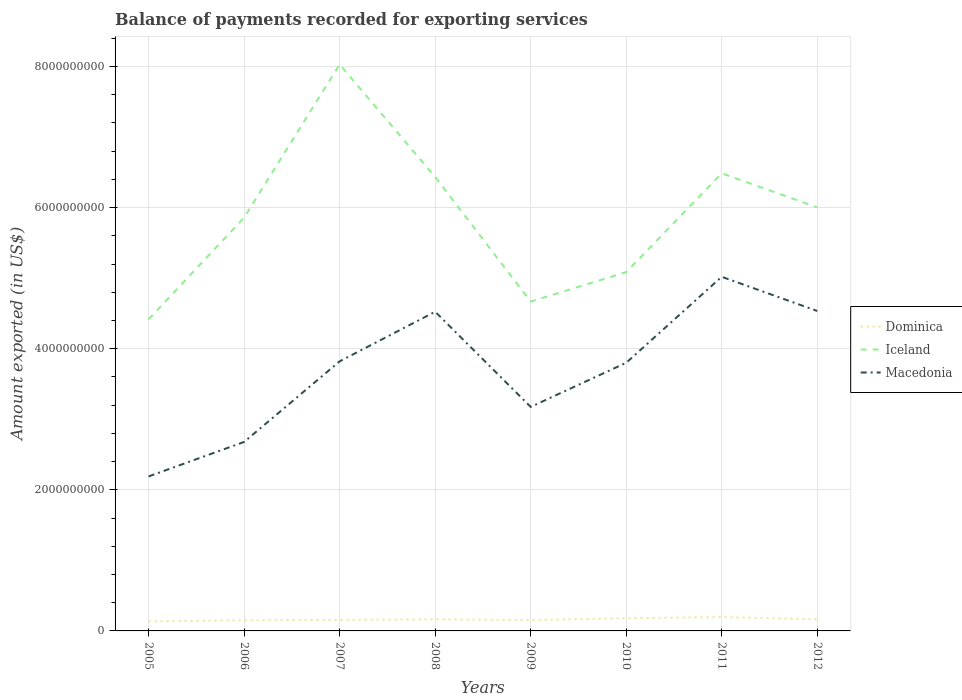Across all years, what is the maximum amount exported in Iceland?
Your answer should be very brief. 4.42e+09. In which year was the amount exported in Iceland maximum?
Your response must be concise. 2005. What is the total amount exported in Dominica in the graph?
Keep it short and to the point. -1.92e+07. What is the difference between the highest and the second highest amount exported in Iceland?
Make the answer very short. 3.61e+09. What is the difference between the highest and the lowest amount exported in Macedonia?
Provide a short and direct response. 5. How many years are there in the graph?
Your answer should be compact. 8. Does the graph contain any zero values?
Your response must be concise. No. Does the graph contain grids?
Offer a terse response. Yes. How are the legend labels stacked?
Keep it short and to the point. Vertical. What is the title of the graph?
Ensure brevity in your answer.  Balance of payments recorded for exporting services. Does "Albania" appear as one of the legend labels in the graph?
Give a very brief answer. No. What is the label or title of the X-axis?
Keep it short and to the point. Years. What is the label or title of the Y-axis?
Your answer should be very brief. Amount exported (in US$). What is the Amount exported (in US$) in Dominica in 2005?
Ensure brevity in your answer.  1.35e+08. What is the Amount exported (in US$) of Iceland in 2005?
Provide a short and direct response. 4.42e+09. What is the Amount exported (in US$) in Macedonia in 2005?
Provide a succinct answer. 2.19e+09. What is the Amount exported (in US$) in Dominica in 2006?
Your answer should be very brief. 1.51e+08. What is the Amount exported (in US$) in Iceland in 2006?
Your answer should be very brief. 5.86e+09. What is the Amount exported (in US$) of Macedonia in 2006?
Give a very brief answer. 2.68e+09. What is the Amount exported (in US$) of Dominica in 2007?
Offer a very short reply. 1.56e+08. What is the Amount exported (in US$) of Iceland in 2007?
Keep it short and to the point. 8.03e+09. What is the Amount exported (in US$) of Macedonia in 2007?
Keep it short and to the point. 3.82e+09. What is the Amount exported (in US$) of Dominica in 2008?
Ensure brevity in your answer.  1.65e+08. What is the Amount exported (in US$) in Iceland in 2008?
Offer a very short reply. 6.43e+09. What is the Amount exported (in US$) in Macedonia in 2008?
Make the answer very short. 4.52e+09. What is the Amount exported (in US$) in Dominica in 2009?
Keep it short and to the point. 1.55e+08. What is the Amount exported (in US$) of Iceland in 2009?
Your answer should be very brief. 4.67e+09. What is the Amount exported (in US$) in Macedonia in 2009?
Keep it short and to the point. 3.18e+09. What is the Amount exported (in US$) of Dominica in 2010?
Keep it short and to the point. 1.80e+08. What is the Amount exported (in US$) of Iceland in 2010?
Make the answer very short. 5.08e+09. What is the Amount exported (in US$) of Macedonia in 2010?
Provide a short and direct response. 3.80e+09. What is the Amount exported (in US$) of Dominica in 2011?
Your answer should be very brief. 1.96e+08. What is the Amount exported (in US$) in Iceland in 2011?
Your response must be concise. 6.49e+09. What is the Amount exported (in US$) of Macedonia in 2011?
Your response must be concise. 5.02e+09. What is the Amount exported (in US$) in Dominica in 2012?
Offer a very short reply. 1.65e+08. What is the Amount exported (in US$) in Iceland in 2012?
Give a very brief answer. 6.00e+09. What is the Amount exported (in US$) of Macedonia in 2012?
Ensure brevity in your answer.  4.53e+09. Across all years, what is the maximum Amount exported (in US$) in Dominica?
Provide a succinct answer. 1.96e+08. Across all years, what is the maximum Amount exported (in US$) of Iceland?
Your response must be concise. 8.03e+09. Across all years, what is the maximum Amount exported (in US$) in Macedonia?
Keep it short and to the point. 5.02e+09. Across all years, what is the minimum Amount exported (in US$) in Dominica?
Make the answer very short. 1.35e+08. Across all years, what is the minimum Amount exported (in US$) in Iceland?
Ensure brevity in your answer.  4.42e+09. Across all years, what is the minimum Amount exported (in US$) of Macedonia?
Provide a succinct answer. 2.19e+09. What is the total Amount exported (in US$) of Dominica in the graph?
Offer a very short reply. 1.30e+09. What is the total Amount exported (in US$) in Iceland in the graph?
Your response must be concise. 4.70e+1. What is the total Amount exported (in US$) in Macedonia in the graph?
Your response must be concise. 2.97e+1. What is the difference between the Amount exported (in US$) of Dominica in 2005 and that in 2006?
Your answer should be very brief. -1.53e+07. What is the difference between the Amount exported (in US$) in Iceland in 2005 and that in 2006?
Offer a terse response. -1.44e+09. What is the difference between the Amount exported (in US$) of Macedonia in 2005 and that in 2006?
Your answer should be compact. -4.89e+08. What is the difference between the Amount exported (in US$) of Dominica in 2005 and that in 2007?
Provide a short and direct response. -2.11e+07. What is the difference between the Amount exported (in US$) in Iceland in 2005 and that in 2007?
Provide a succinct answer. -3.61e+09. What is the difference between the Amount exported (in US$) of Macedonia in 2005 and that in 2007?
Your answer should be compact. -1.63e+09. What is the difference between the Amount exported (in US$) of Dominica in 2005 and that in 2008?
Provide a short and direct response. -2.99e+07. What is the difference between the Amount exported (in US$) of Iceland in 2005 and that in 2008?
Offer a very short reply. -2.02e+09. What is the difference between the Amount exported (in US$) in Macedonia in 2005 and that in 2008?
Provide a short and direct response. -2.33e+09. What is the difference between the Amount exported (in US$) in Dominica in 2005 and that in 2009?
Provide a short and direct response. -1.92e+07. What is the difference between the Amount exported (in US$) in Iceland in 2005 and that in 2009?
Your answer should be very brief. -2.52e+08. What is the difference between the Amount exported (in US$) of Macedonia in 2005 and that in 2009?
Provide a short and direct response. -9.85e+08. What is the difference between the Amount exported (in US$) of Dominica in 2005 and that in 2010?
Your response must be concise. -4.49e+07. What is the difference between the Amount exported (in US$) in Iceland in 2005 and that in 2010?
Make the answer very short. -6.69e+08. What is the difference between the Amount exported (in US$) in Macedonia in 2005 and that in 2010?
Offer a very short reply. -1.61e+09. What is the difference between the Amount exported (in US$) in Dominica in 2005 and that in 2011?
Offer a terse response. -6.06e+07. What is the difference between the Amount exported (in US$) of Iceland in 2005 and that in 2011?
Provide a succinct answer. -2.07e+09. What is the difference between the Amount exported (in US$) of Macedonia in 2005 and that in 2011?
Keep it short and to the point. -2.83e+09. What is the difference between the Amount exported (in US$) of Dominica in 2005 and that in 2012?
Provide a succinct answer. -2.98e+07. What is the difference between the Amount exported (in US$) in Iceland in 2005 and that in 2012?
Give a very brief answer. -1.59e+09. What is the difference between the Amount exported (in US$) of Macedonia in 2005 and that in 2012?
Offer a very short reply. -2.34e+09. What is the difference between the Amount exported (in US$) of Dominica in 2006 and that in 2007?
Your answer should be compact. -5.78e+06. What is the difference between the Amount exported (in US$) in Iceland in 2006 and that in 2007?
Your response must be concise. -2.17e+09. What is the difference between the Amount exported (in US$) of Macedonia in 2006 and that in 2007?
Provide a short and direct response. -1.14e+09. What is the difference between the Amount exported (in US$) in Dominica in 2006 and that in 2008?
Give a very brief answer. -1.46e+07. What is the difference between the Amount exported (in US$) in Iceland in 2006 and that in 2008?
Keep it short and to the point. -5.76e+08. What is the difference between the Amount exported (in US$) of Macedonia in 2006 and that in 2008?
Ensure brevity in your answer.  -1.85e+09. What is the difference between the Amount exported (in US$) in Dominica in 2006 and that in 2009?
Keep it short and to the point. -3.92e+06. What is the difference between the Amount exported (in US$) of Iceland in 2006 and that in 2009?
Your answer should be compact. 1.19e+09. What is the difference between the Amount exported (in US$) of Macedonia in 2006 and that in 2009?
Your answer should be compact. -4.97e+08. What is the difference between the Amount exported (in US$) in Dominica in 2006 and that in 2010?
Keep it short and to the point. -2.96e+07. What is the difference between the Amount exported (in US$) in Iceland in 2006 and that in 2010?
Provide a short and direct response. 7.73e+08. What is the difference between the Amount exported (in US$) in Macedonia in 2006 and that in 2010?
Offer a very short reply. -1.12e+09. What is the difference between the Amount exported (in US$) of Dominica in 2006 and that in 2011?
Provide a short and direct response. -4.53e+07. What is the difference between the Amount exported (in US$) of Iceland in 2006 and that in 2011?
Offer a terse response. -6.27e+08. What is the difference between the Amount exported (in US$) of Macedonia in 2006 and that in 2011?
Offer a very short reply. -2.34e+09. What is the difference between the Amount exported (in US$) in Dominica in 2006 and that in 2012?
Make the answer very short. -1.44e+07. What is the difference between the Amount exported (in US$) in Iceland in 2006 and that in 2012?
Your answer should be very brief. -1.45e+08. What is the difference between the Amount exported (in US$) in Macedonia in 2006 and that in 2012?
Make the answer very short. -1.86e+09. What is the difference between the Amount exported (in US$) of Dominica in 2007 and that in 2008?
Offer a very short reply. -8.77e+06. What is the difference between the Amount exported (in US$) in Iceland in 2007 and that in 2008?
Make the answer very short. 1.60e+09. What is the difference between the Amount exported (in US$) of Macedonia in 2007 and that in 2008?
Your answer should be compact. -7.03e+08. What is the difference between the Amount exported (in US$) of Dominica in 2007 and that in 2009?
Provide a succinct answer. 1.87e+06. What is the difference between the Amount exported (in US$) of Iceland in 2007 and that in 2009?
Provide a succinct answer. 3.36e+09. What is the difference between the Amount exported (in US$) of Macedonia in 2007 and that in 2009?
Make the answer very short. 6.46e+08. What is the difference between the Amount exported (in US$) of Dominica in 2007 and that in 2010?
Offer a very short reply. -2.38e+07. What is the difference between the Amount exported (in US$) of Iceland in 2007 and that in 2010?
Ensure brevity in your answer.  2.94e+09. What is the difference between the Amount exported (in US$) of Macedonia in 2007 and that in 2010?
Your answer should be very brief. 2.02e+07. What is the difference between the Amount exported (in US$) in Dominica in 2007 and that in 2011?
Keep it short and to the point. -3.95e+07. What is the difference between the Amount exported (in US$) of Iceland in 2007 and that in 2011?
Your answer should be compact. 1.54e+09. What is the difference between the Amount exported (in US$) of Macedonia in 2007 and that in 2011?
Provide a succinct answer. -1.20e+09. What is the difference between the Amount exported (in US$) in Dominica in 2007 and that in 2012?
Ensure brevity in your answer.  -8.67e+06. What is the difference between the Amount exported (in US$) in Iceland in 2007 and that in 2012?
Offer a terse response. 2.03e+09. What is the difference between the Amount exported (in US$) in Macedonia in 2007 and that in 2012?
Your response must be concise. -7.14e+08. What is the difference between the Amount exported (in US$) in Dominica in 2008 and that in 2009?
Offer a very short reply. 1.06e+07. What is the difference between the Amount exported (in US$) in Iceland in 2008 and that in 2009?
Ensure brevity in your answer.  1.77e+09. What is the difference between the Amount exported (in US$) of Macedonia in 2008 and that in 2009?
Keep it short and to the point. 1.35e+09. What is the difference between the Amount exported (in US$) in Dominica in 2008 and that in 2010?
Keep it short and to the point. -1.50e+07. What is the difference between the Amount exported (in US$) in Iceland in 2008 and that in 2010?
Provide a short and direct response. 1.35e+09. What is the difference between the Amount exported (in US$) of Macedonia in 2008 and that in 2010?
Offer a terse response. 7.23e+08. What is the difference between the Amount exported (in US$) in Dominica in 2008 and that in 2011?
Keep it short and to the point. -3.07e+07. What is the difference between the Amount exported (in US$) of Iceland in 2008 and that in 2011?
Make the answer very short. -5.18e+07. What is the difference between the Amount exported (in US$) of Macedonia in 2008 and that in 2011?
Offer a very short reply. -4.95e+08. What is the difference between the Amount exported (in US$) of Dominica in 2008 and that in 2012?
Provide a short and direct response. 1.01e+05. What is the difference between the Amount exported (in US$) in Iceland in 2008 and that in 2012?
Ensure brevity in your answer.  4.31e+08. What is the difference between the Amount exported (in US$) of Macedonia in 2008 and that in 2012?
Ensure brevity in your answer.  -1.05e+07. What is the difference between the Amount exported (in US$) in Dominica in 2009 and that in 2010?
Your response must be concise. -2.56e+07. What is the difference between the Amount exported (in US$) in Iceland in 2009 and that in 2010?
Provide a short and direct response. -4.17e+08. What is the difference between the Amount exported (in US$) of Macedonia in 2009 and that in 2010?
Keep it short and to the point. -6.26e+08. What is the difference between the Amount exported (in US$) in Dominica in 2009 and that in 2011?
Provide a short and direct response. -4.14e+07. What is the difference between the Amount exported (in US$) in Iceland in 2009 and that in 2011?
Your answer should be very brief. -1.82e+09. What is the difference between the Amount exported (in US$) in Macedonia in 2009 and that in 2011?
Make the answer very short. -1.84e+09. What is the difference between the Amount exported (in US$) in Dominica in 2009 and that in 2012?
Offer a very short reply. -1.05e+07. What is the difference between the Amount exported (in US$) in Iceland in 2009 and that in 2012?
Your answer should be compact. -1.33e+09. What is the difference between the Amount exported (in US$) of Macedonia in 2009 and that in 2012?
Ensure brevity in your answer.  -1.36e+09. What is the difference between the Amount exported (in US$) of Dominica in 2010 and that in 2011?
Provide a short and direct response. -1.57e+07. What is the difference between the Amount exported (in US$) in Iceland in 2010 and that in 2011?
Give a very brief answer. -1.40e+09. What is the difference between the Amount exported (in US$) in Macedonia in 2010 and that in 2011?
Your answer should be compact. -1.22e+09. What is the difference between the Amount exported (in US$) of Dominica in 2010 and that in 2012?
Your response must be concise. 1.51e+07. What is the difference between the Amount exported (in US$) of Iceland in 2010 and that in 2012?
Your answer should be compact. -9.18e+08. What is the difference between the Amount exported (in US$) of Macedonia in 2010 and that in 2012?
Give a very brief answer. -7.34e+08. What is the difference between the Amount exported (in US$) in Dominica in 2011 and that in 2012?
Offer a very short reply. 3.08e+07. What is the difference between the Amount exported (in US$) of Iceland in 2011 and that in 2012?
Ensure brevity in your answer.  4.83e+08. What is the difference between the Amount exported (in US$) of Macedonia in 2011 and that in 2012?
Ensure brevity in your answer.  4.85e+08. What is the difference between the Amount exported (in US$) in Dominica in 2005 and the Amount exported (in US$) in Iceland in 2006?
Your response must be concise. -5.72e+09. What is the difference between the Amount exported (in US$) in Dominica in 2005 and the Amount exported (in US$) in Macedonia in 2006?
Offer a terse response. -2.54e+09. What is the difference between the Amount exported (in US$) of Iceland in 2005 and the Amount exported (in US$) of Macedonia in 2006?
Make the answer very short. 1.74e+09. What is the difference between the Amount exported (in US$) of Dominica in 2005 and the Amount exported (in US$) of Iceland in 2007?
Give a very brief answer. -7.89e+09. What is the difference between the Amount exported (in US$) in Dominica in 2005 and the Amount exported (in US$) in Macedonia in 2007?
Provide a short and direct response. -3.69e+09. What is the difference between the Amount exported (in US$) in Iceland in 2005 and the Amount exported (in US$) in Macedonia in 2007?
Keep it short and to the point. 5.95e+08. What is the difference between the Amount exported (in US$) in Dominica in 2005 and the Amount exported (in US$) in Iceland in 2008?
Your response must be concise. -6.30e+09. What is the difference between the Amount exported (in US$) of Dominica in 2005 and the Amount exported (in US$) of Macedonia in 2008?
Provide a short and direct response. -4.39e+09. What is the difference between the Amount exported (in US$) of Iceland in 2005 and the Amount exported (in US$) of Macedonia in 2008?
Ensure brevity in your answer.  -1.08e+08. What is the difference between the Amount exported (in US$) of Dominica in 2005 and the Amount exported (in US$) of Iceland in 2009?
Ensure brevity in your answer.  -4.53e+09. What is the difference between the Amount exported (in US$) in Dominica in 2005 and the Amount exported (in US$) in Macedonia in 2009?
Your answer should be compact. -3.04e+09. What is the difference between the Amount exported (in US$) of Iceland in 2005 and the Amount exported (in US$) of Macedonia in 2009?
Keep it short and to the point. 1.24e+09. What is the difference between the Amount exported (in US$) in Dominica in 2005 and the Amount exported (in US$) in Iceland in 2010?
Offer a terse response. -4.95e+09. What is the difference between the Amount exported (in US$) in Dominica in 2005 and the Amount exported (in US$) in Macedonia in 2010?
Give a very brief answer. -3.67e+09. What is the difference between the Amount exported (in US$) in Iceland in 2005 and the Amount exported (in US$) in Macedonia in 2010?
Your response must be concise. 6.15e+08. What is the difference between the Amount exported (in US$) of Dominica in 2005 and the Amount exported (in US$) of Iceland in 2011?
Give a very brief answer. -6.35e+09. What is the difference between the Amount exported (in US$) in Dominica in 2005 and the Amount exported (in US$) in Macedonia in 2011?
Ensure brevity in your answer.  -4.88e+09. What is the difference between the Amount exported (in US$) in Iceland in 2005 and the Amount exported (in US$) in Macedonia in 2011?
Your response must be concise. -6.04e+08. What is the difference between the Amount exported (in US$) of Dominica in 2005 and the Amount exported (in US$) of Iceland in 2012?
Provide a short and direct response. -5.87e+09. What is the difference between the Amount exported (in US$) of Dominica in 2005 and the Amount exported (in US$) of Macedonia in 2012?
Provide a short and direct response. -4.40e+09. What is the difference between the Amount exported (in US$) of Iceland in 2005 and the Amount exported (in US$) of Macedonia in 2012?
Give a very brief answer. -1.19e+08. What is the difference between the Amount exported (in US$) of Dominica in 2006 and the Amount exported (in US$) of Iceland in 2007?
Your answer should be very brief. -7.88e+09. What is the difference between the Amount exported (in US$) of Dominica in 2006 and the Amount exported (in US$) of Macedonia in 2007?
Your response must be concise. -3.67e+09. What is the difference between the Amount exported (in US$) of Iceland in 2006 and the Amount exported (in US$) of Macedonia in 2007?
Make the answer very short. 2.04e+09. What is the difference between the Amount exported (in US$) of Dominica in 2006 and the Amount exported (in US$) of Iceland in 2008?
Your response must be concise. -6.28e+09. What is the difference between the Amount exported (in US$) in Dominica in 2006 and the Amount exported (in US$) in Macedonia in 2008?
Offer a very short reply. -4.37e+09. What is the difference between the Amount exported (in US$) in Iceland in 2006 and the Amount exported (in US$) in Macedonia in 2008?
Your response must be concise. 1.33e+09. What is the difference between the Amount exported (in US$) of Dominica in 2006 and the Amount exported (in US$) of Iceland in 2009?
Your answer should be very brief. -4.52e+09. What is the difference between the Amount exported (in US$) of Dominica in 2006 and the Amount exported (in US$) of Macedonia in 2009?
Provide a short and direct response. -3.02e+09. What is the difference between the Amount exported (in US$) of Iceland in 2006 and the Amount exported (in US$) of Macedonia in 2009?
Provide a short and direct response. 2.68e+09. What is the difference between the Amount exported (in US$) of Dominica in 2006 and the Amount exported (in US$) of Iceland in 2010?
Provide a succinct answer. -4.93e+09. What is the difference between the Amount exported (in US$) in Dominica in 2006 and the Amount exported (in US$) in Macedonia in 2010?
Offer a very short reply. -3.65e+09. What is the difference between the Amount exported (in US$) in Iceland in 2006 and the Amount exported (in US$) in Macedonia in 2010?
Offer a very short reply. 2.06e+09. What is the difference between the Amount exported (in US$) of Dominica in 2006 and the Amount exported (in US$) of Iceland in 2011?
Give a very brief answer. -6.33e+09. What is the difference between the Amount exported (in US$) in Dominica in 2006 and the Amount exported (in US$) in Macedonia in 2011?
Offer a very short reply. -4.87e+09. What is the difference between the Amount exported (in US$) of Iceland in 2006 and the Amount exported (in US$) of Macedonia in 2011?
Your answer should be very brief. 8.39e+08. What is the difference between the Amount exported (in US$) in Dominica in 2006 and the Amount exported (in US$) in Iceland in 2012?
Your answer should be compact. -5.85e+09. What is the difference between the Amount exported (in US$) of Dominica in 2006 and the Amount exported (in US$) of Macedonia in 2012?
Make the answer very short. -4.38e+09. What is the difference between the Amount exported (in US$) in Iceland in 2006 and the Amount exported (in US$) in Macedonia in 2012?
Give a very brief answer. 1.32e+09. What is the difference between the Amount exported (in US$) in Dominica in 2007 and the Amount exported (in US$) in Iceland in 2008?
Keep it short and to the point. -6.28e+09. What is the difference between the Amount exported (in US$) of Dominica in 2007 and the Amount exported (in US$) of Macedonia in 2008?
Offer a very short reply. -4.37e+09. What is the difference between the Amount exported (in US$) of Iceland in 2007 and the Amount exported (in US$) of Macedonia in 2008?
Ensure brevity in your answer.  3.51e+09. What is the difference between the Amount exported (in US$) of Dominica in 2007 and the Amount exported (in US$) of Iceland in 2009?
Provide a short and direct response. -4.51e+09. What is the difference between the Amount exported (in US$) of Dominica in 2007 and the Amount exported (in US$) of Macedonia in 2009?
Your answer should be very brief. -3.02e+09. What is the difference between the Amount exported (in US$) of Iceland in 2007 and the Amount exported (in US$) of Macedonia in 2009?
Your answer should be compact. 4.85e+09. What is the difference between the Amount exported (in US$) in Dominica in 2007 and the Amount exported (in US$) in Iceland in 2010?
Provide a succinct answer. -4.93e+09. What is the difference between the Amount exported (in US$) in Dominica in 2007 and the Amount exported (in US$) in Macedonia in 2010?
Your response must be concise. -3.64e+09. What is the difference between the Amount exported (in US$) of Iceland in 2007 and the Amount exported (in US$) of Macedonia in 2010?
Offer a very short reply. 4.23e+09. What is the difference between the Amount exported (in US$) in Dominica in 2007 and the Amount exported (in US$) in Iceland in 2011?
Offer a terse response. -6.33e+09. What is the difference between the Amount exported (in US$) in Dominica in 2007 and the Amount exported (in US$) in Macedonia in 2011?
Provide a succinct answer. -4.86e+09. What is the difference between the Amount exported (in US$) of Iceland in 2007 and the Amount exported (in US$) of Macedonia in 2011?
Offer a terse response. 3.01e+09. What is the difference between the Amount exported (in US$) in Dominica in 2007 and the Amount exported (in US$) in Iceland in 2012?
Your answer should be compact. -5.85e+09. What is the difference between the Amount exported (in US$) of Dominica in 2007 and the Amount exported (in US$) of Macedonia in 2012?
Your answer should be compact. -4.38e+09. What is the difference between the Amount exported (in US$) in Iceland in 2007 and the Amount exported (in US$) in Macedonia in 2012?
Offer a terse response. 3.49e+09. What is the difference between the Amount exported (in US$) in Dominica in 2008 and the Amount exported (in US$) in Iceland in 2009?
Provide a short and direct response. -4.50e+09. What is the difference between the Amount exported (in US$) in Dominica in 2008 and the Amount exported (in US$) in Macedonia in 2009?
Ensure brevity in your answer.  -3.01e+09. What is the difference between the Amount exported (in US$) in Iceland in 2008 and the Amount exported (in US$) in Macedonia in 2009?
Ensure brevity in your answer.  3.26e+09. What is the difference between the Amount exported (in US$) in Dominica in 2008 and the Amount exported (in US$) in Iceland in 2010?
Ensure brevity in your answer.  -4.92e+09. What is the difference between the Amount exported (in US$) in Dominica in 2008 and the Amount exported (in US$) in Macedonia in 2010?
Your answer should be very brief. -3.64e+09. What is the difference between the Amount exported (in US$) in Iceland in 2008 and the Amount exported (in US$) in Macedonia in 2010?
Provide a short and direct response. 2.63e+09. What is the difference between the Amount exported (in US$) of Dominica in 2008 and the Amount exported (in US$) of Iceland in 2011?
Offer a terse response. -6.32e+09. What is the difference between the Amount exported (in US$) in Dominica in 2008 and the Amount exported (in US$) in Macedonia in 2011?
Make the answer very short. -4.85e+09. What is the difference between the Amount exported (in US$) of Iceland in 2008 and the Amount exported (in US$) of Macedonia in 2011?
Keep it short and to the point. 1.41e+09. What is the difference between the Amount exported (in US$) of Dominica in 2008 and the Amount exported (in US$) of Iceland in 2012?
Ensure brevity in your answer.  -5.84e+09. What is the difference between the Amount exported (in US$) of Dominica in 2008 and the Amount exported (in US$) of Macedonia in 2012?
Make the answer very short. -4.37e+09. What is the difference between the Amount exported (in US$) in Iceland in 2008 and the Amount exported (in US$) in Macedonia in 2012?
Your response must be concise. 1.90e+09. What is the difference between the Amount exported (in US$) in Dominica in 2009 and the Amount exported (in US$) in Iceland in 2010?
Offer a terse response. -4.93e+09. What is the difference between the Amount exported (in US$) of Dominica in 2009 and the Amount exported (in US$) of Macedonia in 2010?
Your response must be concise. -3.65e+09. What is the difference between the Amount exported (in US$) of Iceland in 2009 and the Amount exported (in US$) of Macedonia in 2010?
Your answer should be compact. 8.67e+08. What is the difference between the Amount exported (in US$) in Dominica in 2009 and the Amount exported (in US$) in Iceland in 2011?
Offer a very short reply. -6.33e+09. What is the difference between the Amount exported (in US$) of Dominica in 2009 and the Amount exported (in US$) of Macedonia in 2011?
Make the answer very short. -4.86e+09. What is the difference between the Amount exported (in US$) in Iceland in 2009 and the Amount exported (in US$) in Macedonia in 2011?
Your answer should be very brief. -3.51e+08. What is the difference between the Amount exported (in US$) in Dominica in 2009 and the Amount exported (in US$) in Iceland in 2012?
Offer a terse response. -5.85e+09. What is the difference between the Amount exported (in US$) of Dominica in 2009 and the Amount exported (in US$) of Macedonia in 2012?
Your response must be concise. -4.38e+09. What is the difference between the Amount exported (in US$) of Iceland in 2009 and the Amount exported (in US$) of Macedonia in 2012?
Your response must be concise. 1.33e+08. What is the difference between the Amount exported (in US$) in Dominica in 2010 and the Amount exported (in US$) in Iceland in 2011?
Make the answer very short. -6.31e+09. What is the difference between the Amount exported (in US$) of Dominica in 2010 and the Amount exported (in US$) of Macedonia in 2011?
Your response must be concise. -4.84e+09. What is the difference between the Amount exported (in US$) in Iceland in 2010 and the Amount exported (in US$) in Macedonia in 2011?
Offer a very short reply. 6.56e+07. What is the difference between the Amount exported (in US$) of Dominica in 2010 and the Amount exported (in US$) of Iceland in 2012?
Give a very brief answer. -5.82e+09. What is the difference between the Amount exported (in US$) in Dominica in 2010 and the Amount exported (in US$) in Macedonia in 2012?
Give a very brief answer. -4.35e+09. What is the difference between the Amount exported (in US$) in Iceland in 2010 and the Amount exported (in US$) in Macedonia in 2012?
Provide a succinct answer. 5.50e+08. What is the difference between the Amount exported (in US$) in Dominica in 2011 and the Amount exported (in US$) in Iceland in 2012?
Keep it short and to the point. -5.81e+09. What is the difference between the Amount exported (in US$) in Dominica in 2011 and the Amount exported (in US$) in Macedonia in 2012?
Keep it short and to the point. -4.34e+09. What is the difference between the Amount exported (in US$) in Iceland in 2011 and the Amount exported (in US$) in Macedonia in 2012?
Keep it short and to the point. 1.95e+09. What is the average Amount exported (in US$) of Dominica per year?
Your answer should be compact. 1.63e+08. What is the average Amount exported (in US$) in Iceland per year?
Ensure brevity in your answer.  5.87e+09. What is the average Amount exported (in US$) in Macedonia per year?
Make the answer very short. 3.72e+09. In the year 2005, what is the difference between the Amount exported (in US$) in Dominica and Amount exported (in US$) in Iceland?
Provide a short and direct response. -4.28e+09. In the year 2005, what is the difference between the Amount exported (in US$) of Dominica and Amount exported (in US$) of Macedonia?
Give a very brief answer. -2.05e+09. In the year 2005, what is the difference between the Amount exported (in US$) of Iceland and Amount exported (in US$) of Macedonia?
Your response must be concise. 2.23e+09. In the year 2006, what is the difference between the Amount exported (in US$) in Dominica and Amount exported (in US$) in Iceland?
Provide a short and direct response. -5.71e+09. In the year 2006, what is the difference between the Amount exported (in US$) in Dominica and Amount exported (in US$) in Macedonia?
Give a very brief answer. -2.53e+09. In the year 2006, what is the difference between the Amount exported (in US$) in Iceland and Amount exported (in US$) in Macedonia?
Your answer should be compact. 3.18e+09. In the year 2007, what is the difference between the Amount exported (in US$) of Dominica and Amount exported (in US$) of Iceland?
Ensure brevity in your answer.  -7.87e+09. In the year 2007, what is the difference between the Amount exported (in US$) of Dominica and Amount exported (in US$) of Macedonia?
Give a very brief answer. -3.66e+09. In the year 2007, what is the difference between the Amount exported (in US$) in Iceland and Amount exported (in US$) in Macedonia?
Offer a terse response. 4.21e+09. In the year 2008, what is the difference between the Amount exported (in US$) in Dominica and Amount exported (in US$) in Iceland?
Offer a very short reply. -6.27e+09. In the year 2008, what is the difference between the Amount exported (in US$) in Dominica and Amount exported (in US$) in Macedonia?
Offer a terse response. -4.36e+09. In the year 2008, what is the difference between the Amount exported (in US$) of Iceland and Amount exported (in US$) of Macedonia?
Your answer should be very brief. 1.91e+09. In the year 2009, what is the difference between the Amount exported (in US$) in Dominica and Amount exported (in US$) in Iceland?
Keep it short and to the point. -4.51e+09. In the year 2009, what is the difference between the Amount exported (in US$) in Dominica and Amount exported (in US$) in Macedonia?
Provide a succinct answer. -3.02e+09. In the year 2009, what is the difference between the Amount exported (in US$) in Iceland and Amount exported (in US$) in Macedonia?
Keep it short and to the point. 1.49e+09. In the year 2010, what is the difference between the Amount exported (in US$) in Dominica and Amount exported (in US$) in Iceland?
Offer a terse response. -4.90e+09. In the year 2010, what is the difference between the Amount exported (in US$) in Dominica and Amount exported (in US$) in Macedonia?
Your response must be concise. -3.62e+09. In the year 2010, what is the difference between the Amount exported (in US$) of Iceland and Amount exported (in US$) of Macedonia?
Give a very brief answer. 1.28e+09. In the year 2011, what is the difference between the Amount exported (in US$) in Dominica and Amount exported (in US$) in Iceland?
Ensure brevity in your answer.  -6.29e+09. In the year 2011, what is the difference between the Amount exported (in US$) in Dominica and Amount exported (in US$) in Macedonia?
Keep it short and to the point. -4.82e+09. In the year 2011, what is the difference between the Amount exported (in US$) in Iceland and Amount exported (in US$) in Macedonia?
Provide a short and direct response. 1.47e+09. In the year 2012, what is the difference between the Amount exported (in US$) in Dominica and Amount exported (in US$) in Iceland?
Offer a terse response. -5.84e+09. In the year 2012, what is the difference between the Amount exported (in US$) in Dominica and Amount exported (in US$) in Macedonia?
Offer a very short reply. -4.37e+09. In the year 2012, what is the difference between the Amount exported (in US$) in Iceland and Amount exported (in US$) in Macedonia?
Your answer should be compact. 1.47e+09. What is the ratio of the Amount exported (in US$) in Dominica in 2005 to that in 2006?
Ensure brevity in your answer.  0.9. What is the ratio of the Amount exported (in US$) of Iceland in 2005 to that in 2006?
Offer a terse response. 0.75. What is the ratio of the Amount exported (in US$) of Macedonia in 2005 to that in 2006?
Give a very brief answer. 0.82. What is the ratio of the Amount exported (in US$) in Dominica in 2005 to that in 2007?
Keep it short and to the point. 0.87. What is the ratio of the Amount exported (in US$) in Iceland in 2005 to that in 2007?
Your response must be concise. 0.55. What is the ratio of the Amount exported (in US$) in Macedonia in 2005 to that in 2007?
Provide a short and direct response. 0.57. What is the ratio of the Amount exported (in US$) in Dominica in 2005 to that in 2008?
Provide a short and direct response. 0.82. What is the ratio of the Amount exported (in US$) in Iceland in 2005 to that in 2008?
Provide a succinct answer. 0.69. What is the ratio of the Amount exported (in US$) of Macedonia in 2005 to that in 2008?
Your answer should be compact. 0.48. What is the ratio of the Amount exported (in US$) in Dominica in 2005 to that in 2009?
Give a very brief answer. 0.88. What is the ratio of the Amount exported (in US$) in Iceland in 2005 to that in 2009?
Ensure brevity in your answer.  0.95. What is the ratio of the Amount exported (in US$) in Macedonia in 2005 to that in 2009?
Your answer should be compact. 0.69. What is the ratio of the Amount exported (in US$) in Dominica in 2005 to that in 2010?
Keep it short and to the point. 0.75. What is the ratio of the Amount exported (in US$) of Iceland in 2005 to that in 2010?
Offer a very short reply. 0.87. What is the ratio of the Amount exported (in US$) in Macedonia in 2005 to that in 2010?
Your answer should be very brief. 0.58. What is the ratio of the Amount exported (in US$) in Dominica in 2005 to that in 2011?
Your response must be concise. 0.69. What is the ratio of the Amount exported (in US$) in Iceland in 2005 to that in 2011?
Offer a very short reply. 0.68. What is the ratio of the Amount exported (in US$) in Macedonia in 2005 to that in 2011?
Offer a terse response. 0.44. What is the ratio of the Amount exported (in US$) of Dominica in 2005 to that in 2012?
Ensure brevity in your answer.  0.82. What is the ratio of the Amount exported (in US$) in Iceland in 2005 to that in 2012?
Provide a succinct answer. 0.74. What is the ratio of the Amount exported (in US$) of Macedonia in 2005 to that in 2012?
Ensure brevity in your answer.  0.48. What is the ratio of the Amount exported (in US$) of Iceland in 2006 to that in 2007?
Provide a succinct answer. 0.73. What is the ratio of the Amount exported (in US$) of Macedonia in 2006 to that in 2007?
Give a very brief answer. 0.7. What is the ratio of the Amount exported (in US$) of Dominica in 2006 to that in 2008?
Your response must be concise. 0.91. What is the ratio of the Amount exported (in US$) of Iceland in 2006 to that in 2008?
Give a very brief answer. 0.91. What is the ratio of the Amount exported (in US$) of Macedonia in 2006 to that in 2008?
Provide a short and direct response. 0.59. What is the ratio of the Amount exported (in US$) of Dominica in 2006 to that in 2009?
Ensure brevity in your answer.  0.97. What is the ratio of the Amount exported (in US$) in Iceland in 2006 to that in 2009?
Your response must be concise. 1.25. What is the ratio of the Amount exported (in US$) of Macedonia in 2006 to that in 2009?
Provide a succinct answer. 0.84. What is the ratio of the Amount exported (in US$) in Dominica in 2006 to that in 2010?
Provide a succinct answer. 0.84. What is the ratio of the Amount exported (in US$) in Iceland in 2006 to that in 2010?
Provide a short and direct response. 1.15. What is the ratio of the Amount exported (in US$) of Macedonia in 2006 to that in 2010?
Make the answer very short. 0.7. What is the ratio of the Amount exported (in US$) in Dominica in 2006 to that in 2011?
Provide a short and direct response. 0.77. What is the ratio of the Amount exported (in US$) in Iceland in 2006 to that in 2011?
Offer a very short reply. 0.9. What is the ratio of the Amount exported (in US$) in Macedonia in 2006 to that in 2011?
Offer a terse response. 0.53. What is the ratio of the Amount exported (in US$) of Dominica in 2006 to that in 2012?
Offer a terse response. 0.91. What is the ratio of the Amount exported (in US$) in Iceland in 2006 to that in 2012?
Your answer should be compact. 0.98. What is the ratio of the Amount exported (in US$) in Macedonia in 2006 to that in 2012?
Give a very brief answer. 0.59. What is the ratio of the Amount exported (in US$) of Dominica in 2007 to that in 2008?
Provide a succinct answer. 0.95. What is the ratio of the Amount exported (in US$) of Iceland in 2007 to that in 2008?
Provide a short and direct response. 1.25. What is the ratio of the Amount exported (in US$) of Macedonia in 2007 to that in 2008?
Your response must be concise. 0.84. What is the ratio of the Amount exported (in US$) in Dominica in 2007 to that in 2009?
Keep it short and to the point. 1.01. What is the ratio of the Amount exported (in US$) in Iceland in 2007 to that in 2009?
Your answer should be very brief. 1.72. What is the ratio of the Amount exported (in US$) of Macedonia in 2007 to that in 2009?
Keep it short and to the point. 1.2. What is the ratio of the Amount exported (in US$) of Dominica in 2007 to that in 2010?
Your response must be concise. 0.87. What is the ratio of the Amount exported (in US$) of Iceland in 2007 to that in 2010?
Your response must be concise. 1.58. What is the ratio of the Amount exported (in US$) of Dominica in 2007 to that in 2011?
Your answer should be very brief. 0.8. What is the ratio of the Amount exported (in US$) in Iceland in 2007 to that in 2011?
Your response must be concise. 1.24. What is the ratio of the Amount exported (in US$) of Macedonia in 2007 to that in 2011?
Offer a very short reply. 0.76. What is the ratio of the Amount exported (in US$) of Dominica in 2007 to that in 2012?
Your answer should be compact. 0.95. What is the ratio of the Amount exported (in US$) in Iceland in 2007 to that in 2012?
Offer a very short reply. 1.34. What is the ratio of the Amount exported (in US$) in Macedonia in 2007 to that in 2012?
Offer a very short reply. 0.84. What is the ratio of the Amount exported (in US$) of Dominica in 2008 to that in 2009?
Your answer should be compact. 1.07. What is the ratio of the Amount exported (in US$) of Iceland in 2008 to that in 2009?
Your answer should be compact. 1.38. What is the ratio of the Amount exported (in US$) in Macedonia in 2008 to that in 2009?
Provide a short and direct response. 1.42. What is the ratio of the Amount exported (in US$) in Dominica in 2008 to that in 2010?
Your response must be concise. 0.92. What is the ratio of the Amount exported (in US$) in Iceland in 2008 to that in 2010?
Offer a very short reply. 1.27. What is the ratio of the Amount exported (in US$) in Macedonia in 2008 to that in 2010?
Provide a succinct answer. 1.19. What is the ratio of the Amount exported (in US$) in Dominica in 2008 to that in 2011?
Your answer should be compact. 0.84. What is the ratio of the Amount exported (in US$) of Macedonia in 2008 to that in 2011?
Keep it short and to the point. 0.9. What is the ratio of the Amount exported (in US$) in Dominica in 2008 to that in 2012?
Offer a very short reply. 1. What is the ratio of the Amount exported (in US$) of Iceland in 2008 to that in 2012?
Your response must be concise. 1.07. What is the ratio of the Amount exported (in US$) of Macedonia in 2008 to that in 2012?
Give a very brief answer. 1. What is the ratio of the Amount exported (in US$) of Dominica in 2009 to that in 2010?
Your response must be concise. 0.86. What is the ratio of the Amount exported (in US$) in Iceland in 2009 to that in 2010?
Your response must be concise. 0.92. What is the ratio of the Amount exported (in US$) of Macedonia in 2009 to that in 2010?
Offer a very short reply. 0.84. What is the ratio of the Amount exported (in US$) in Dominica in 2009 to that in 2011?
Your answer should be compact. 0.79. What is the ratio of the Amount exported (in US$) of Iceland in 2009 to that in 2011?
Provide a succinct answer. 0.72. What is the ratio of the Amount exported (in US$) in Macedonia in 2009 to that in 2011?
Give a very brief answer. 0.63. What is the ratio of the Amount exported (in US$) in Dominica in 2009 to that in 2012?
Make the answer very short. 0.94. What is the ratio of the Amount exported (in US$) in Iceland in 2009 to that in 2012?
Your response must be concise. 0.78. What is the ratio of the Amount exported (in US$) of Macedonia in 2009 to that in 2012?
Your answer should be compact. 0.7. What is the ratio of the Amount exported (in US$) of Dominica in 2010 to that in 2011?
Offer a terse response. 0.92. What is the ratio of the Amount exported (in US$) in Iceland in 2010 to that in 2011?
Offer a terse response. 0.78. What is the ratio of the Amount exported (in US$) in Macedonia in 2010 to that in 2011?
Make the answer very short. 0.76. What is the ratio of the Amount exported (in US$) in Dominica in 2010 to that in 2012?
Provide a short and direct response. 1.09. What is the ratio of the Amount exported (in US$) of Iceland in 2010 to that in 2012?
Your answer should be very brief. 0.85. What is the ratio of the Amount exported (in US$) of Macedonia in 2010 to that in 2012?
Provide a short and direct response. 0.84. What is the ratio of the Amount exported (in US$) in Dominica in 2011 to that in 2012?
Ensure brevity in your answer.  1.19. What is the ratio of the Amount exported (in US$) in Iceland in 2011 to that in 2012?
Your answer should be very brief. 1.08. What is the ratio of the Amount exported (in US$) in Macedonia in 2011 to that in 2012?
Make the answer very short. 1.11. What is the difference between the highest and the second highest Amount exported (in US$) in Dominica?
Offer a terse response. 1.57e+07. What is the difference between the highest and the second highest Amount exported (in US$) in Iceland?
Ensure brevity in your answer.  1.54e+09. What is the difference between the highest and the second highest Amount exported (in US$) of Macedonia?
Offer a terse response. 4.85e+08. What is the difference between the highest and the lowest Amount exported (in US$) of Dominica?
Keep it short and to the point. 6.06e+07. What is the difference between the highest and the lowest Amount exported (in US$) in Iceland?
Your answer should be compact. 3.61e+09. What is the difference between the highest and the lowest Amount exported (in US$) of Macedonia?
Ensure brevity in your answer.  2.83e+09. 